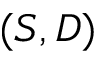<formula> <loc_0><loc_0><loc_500><loc_500>( S , D )</formula> 